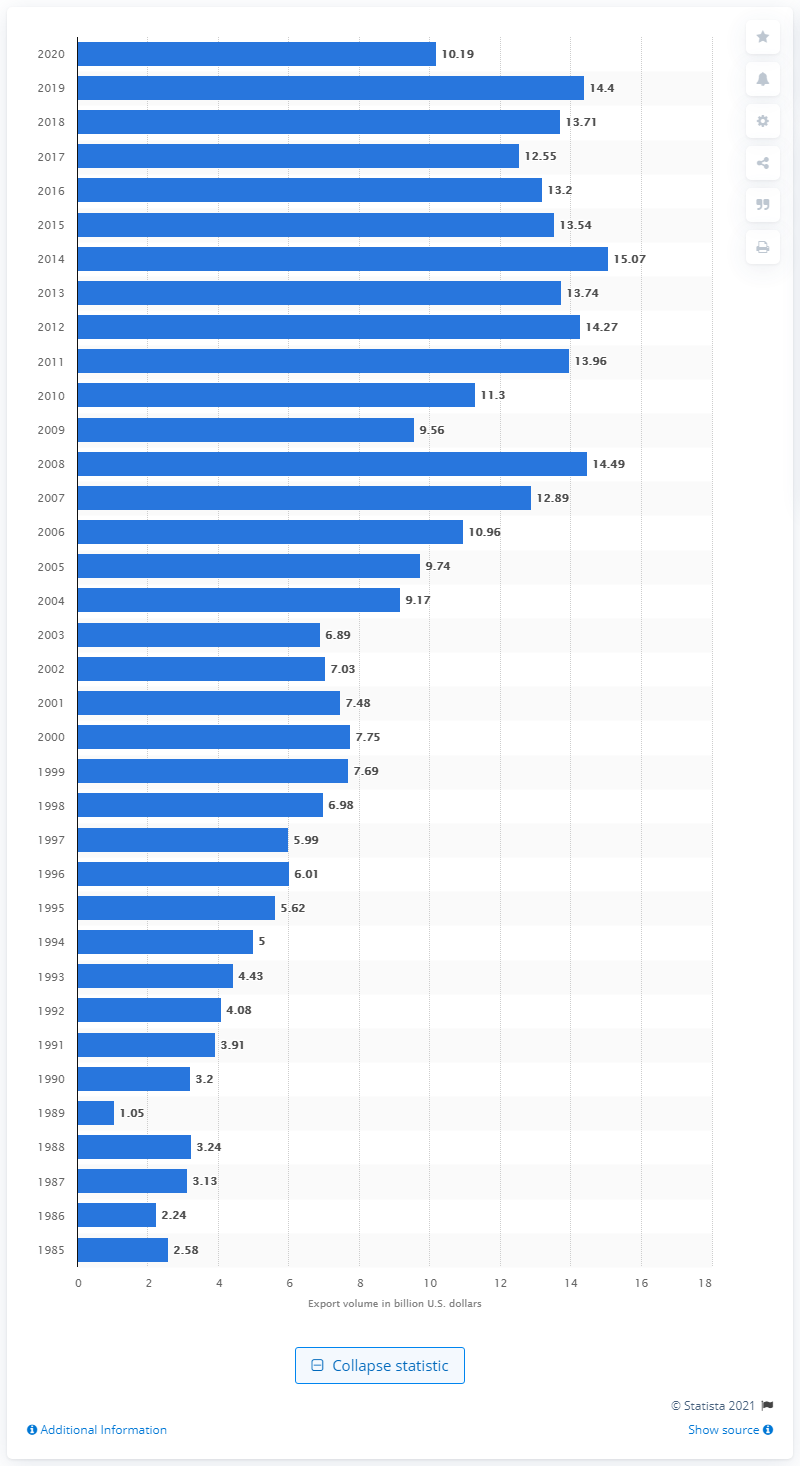Mention a couple of crucial points in this snapshot. In 2020, the United States exported $10.19 billion worth of goods to Israel. 